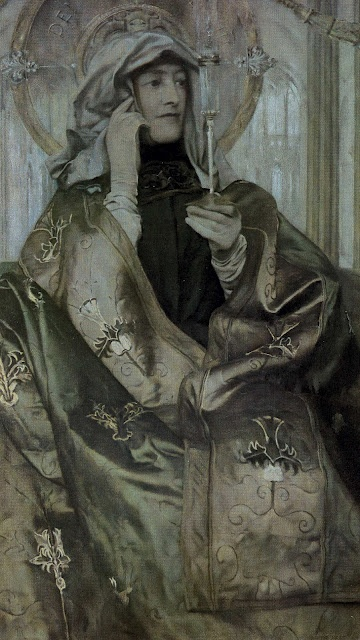What's happening in the scene? The image depicts a woman dressed in medieval attire, exuding an air of elegance and serenity. She is wearing a long, flowing pale green robe intricately decorated with gold embroidery. A distinguished headdress with a veil covers her head and shoulders, enhancing the medieval essence of her appearance. The woman is holding a delicate white flower in her hand, which adds to the serene and reflective mood of the portrait. The background is a subtle pale gray with a soft pattern of leaves and branches, which complements the detailed realism of the art. This captivating piece of portraiture masterfully captures the grace and regality of the woman's figure. 